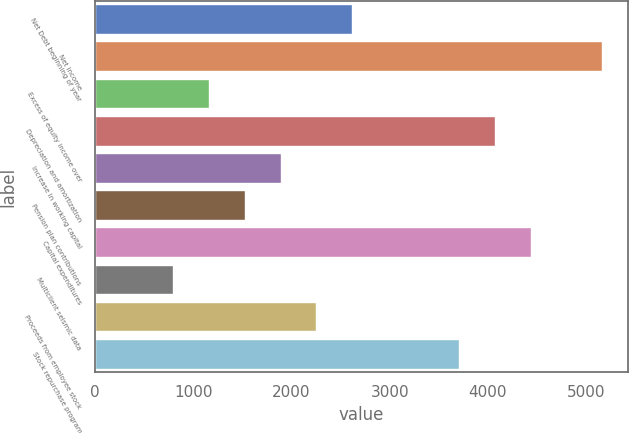<chart> <loc_0><loc_0><loc_500><loc_500><bar_chart><fcel>Net Debt beginning of year<fcel>Net income<fcel>Excess of equity income over<fcel>Depreciation and amortization<fcel>Increase in working capital<fcel>Pension plan contributions<fcel>Capital expenditures<fcel>Multiclient seismic data<fcel>Proceeds from employee stock<fcel>Stock repurchase program<nl><fcel>2616.8<fcel>5167.6<fcel>1159.2<fcel>4074.4<fcel>1888<fcel>1523.6<fcel>4438.8<fcel>794.8<fcel>2252.4<fcel>3710<nl></chart> 